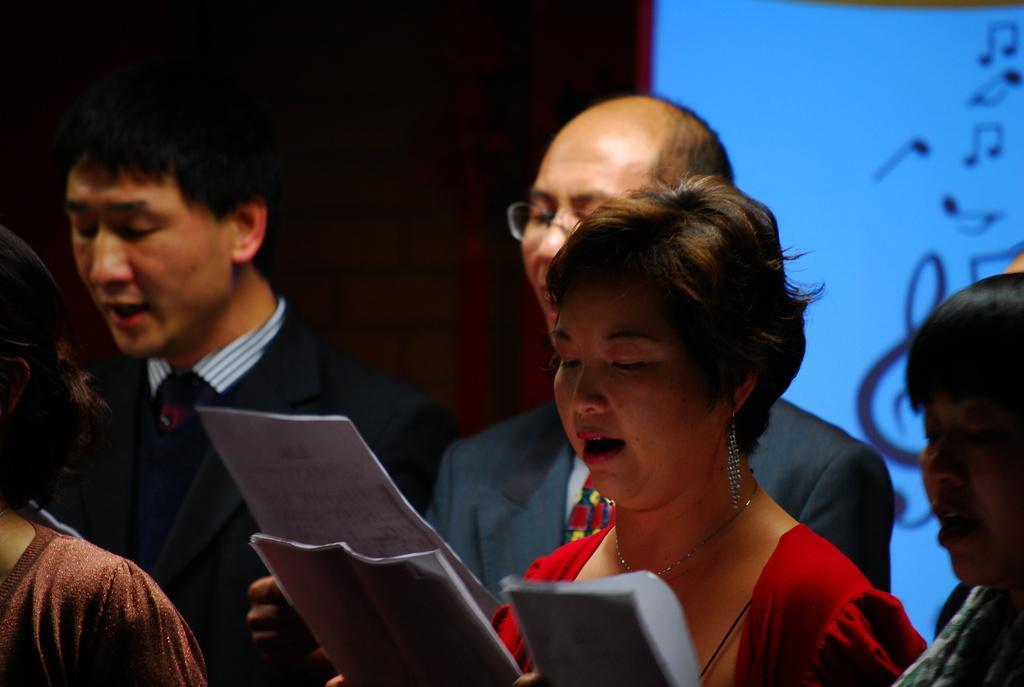Can you describe this image briefly? In this image we can see there are people standing and holding papers and singing. And at the back we can see the screen with music symbols. 